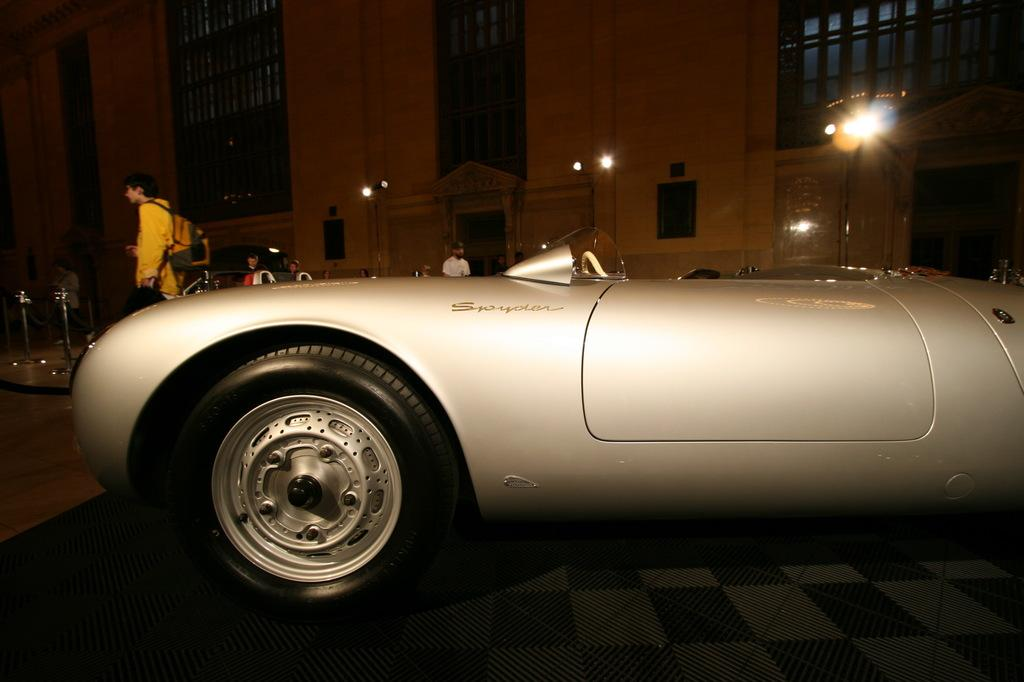What type of vehicle is in the image? There is a gray color vehicle in the image. Where is the vehicle located? The vehicle is parked on the floor. What can be seen in the background of the image? There are lights attached to poles and a building visible in the background of the image. What type of dirt can be seen on the vehicle in the image? There is no dirt visible on the vehicle in the image. Is there a gate present in the image? There is no gate present in the image. 